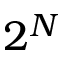<formula> <loc_0><loc_0><loc_500><loc_500>2 ^ { N }</formula> 